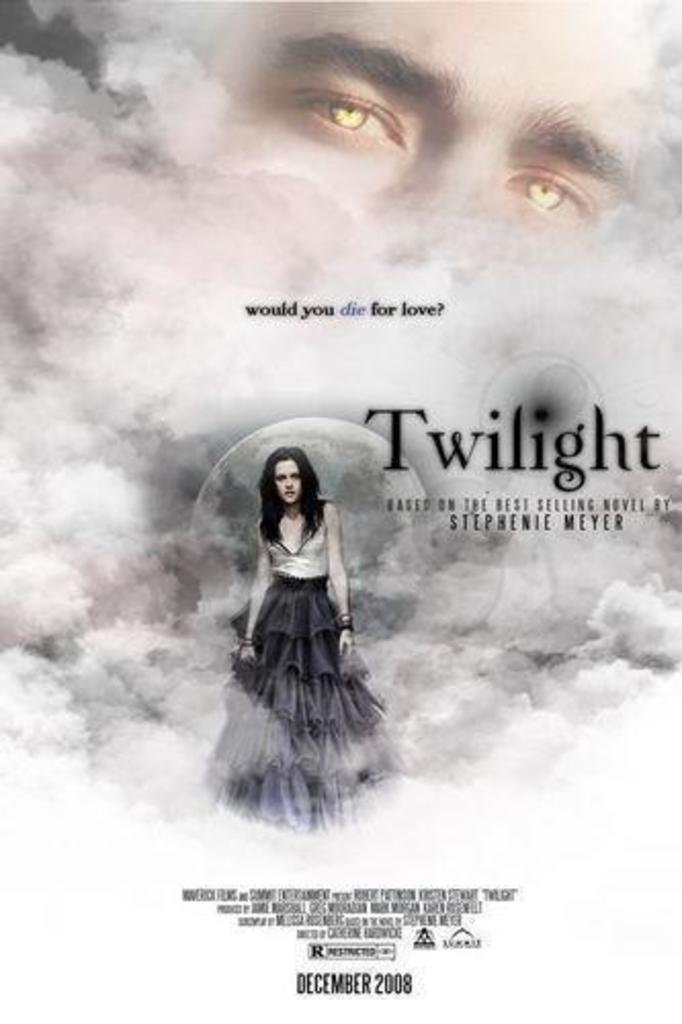What is depicted on the poster in the image? The poster contains clouds, a moon, and two persons. What is the color scheme of the poster? The provided facts do not mention the color scheme of the poster. Is there any text present in the image? Yes, there is some text in the image. What type of crate is being used to guide the health of the two persons in the image? There is no crate, guide, or health-related information present in the image. The image features a poster with clouds, a moon, and two persons, along with some text. 